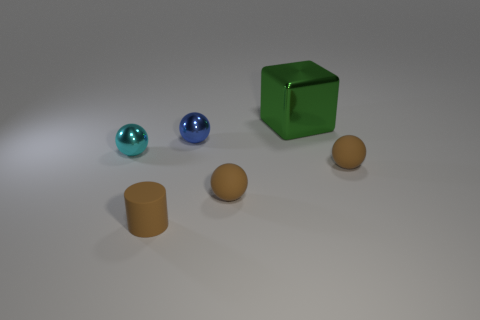Add 2 large shiny cubes. How many objects exist? 8 Subtract 1 cylinders. How many cylinders are left? 0 Subtract all blue spheres. How many spheres are left? 3 Subtract all yellow cylinders. How many brown blocks are left? 0 Subtract all blue matte balls. Subtract all cyan spheres. How many objects are left? 5 Add 4 brown matte objects. How many brown matte objects are left? 7 Add 4 blue shiny objects. How many blue shiny objects exist? 5 Subtract 0 red balls. How many objects are left? 6 Subtract all spheres. How many objects are left? 2 Subtract all gray blocks. Subtract all cyan spheres. How many blocks are left? 1 